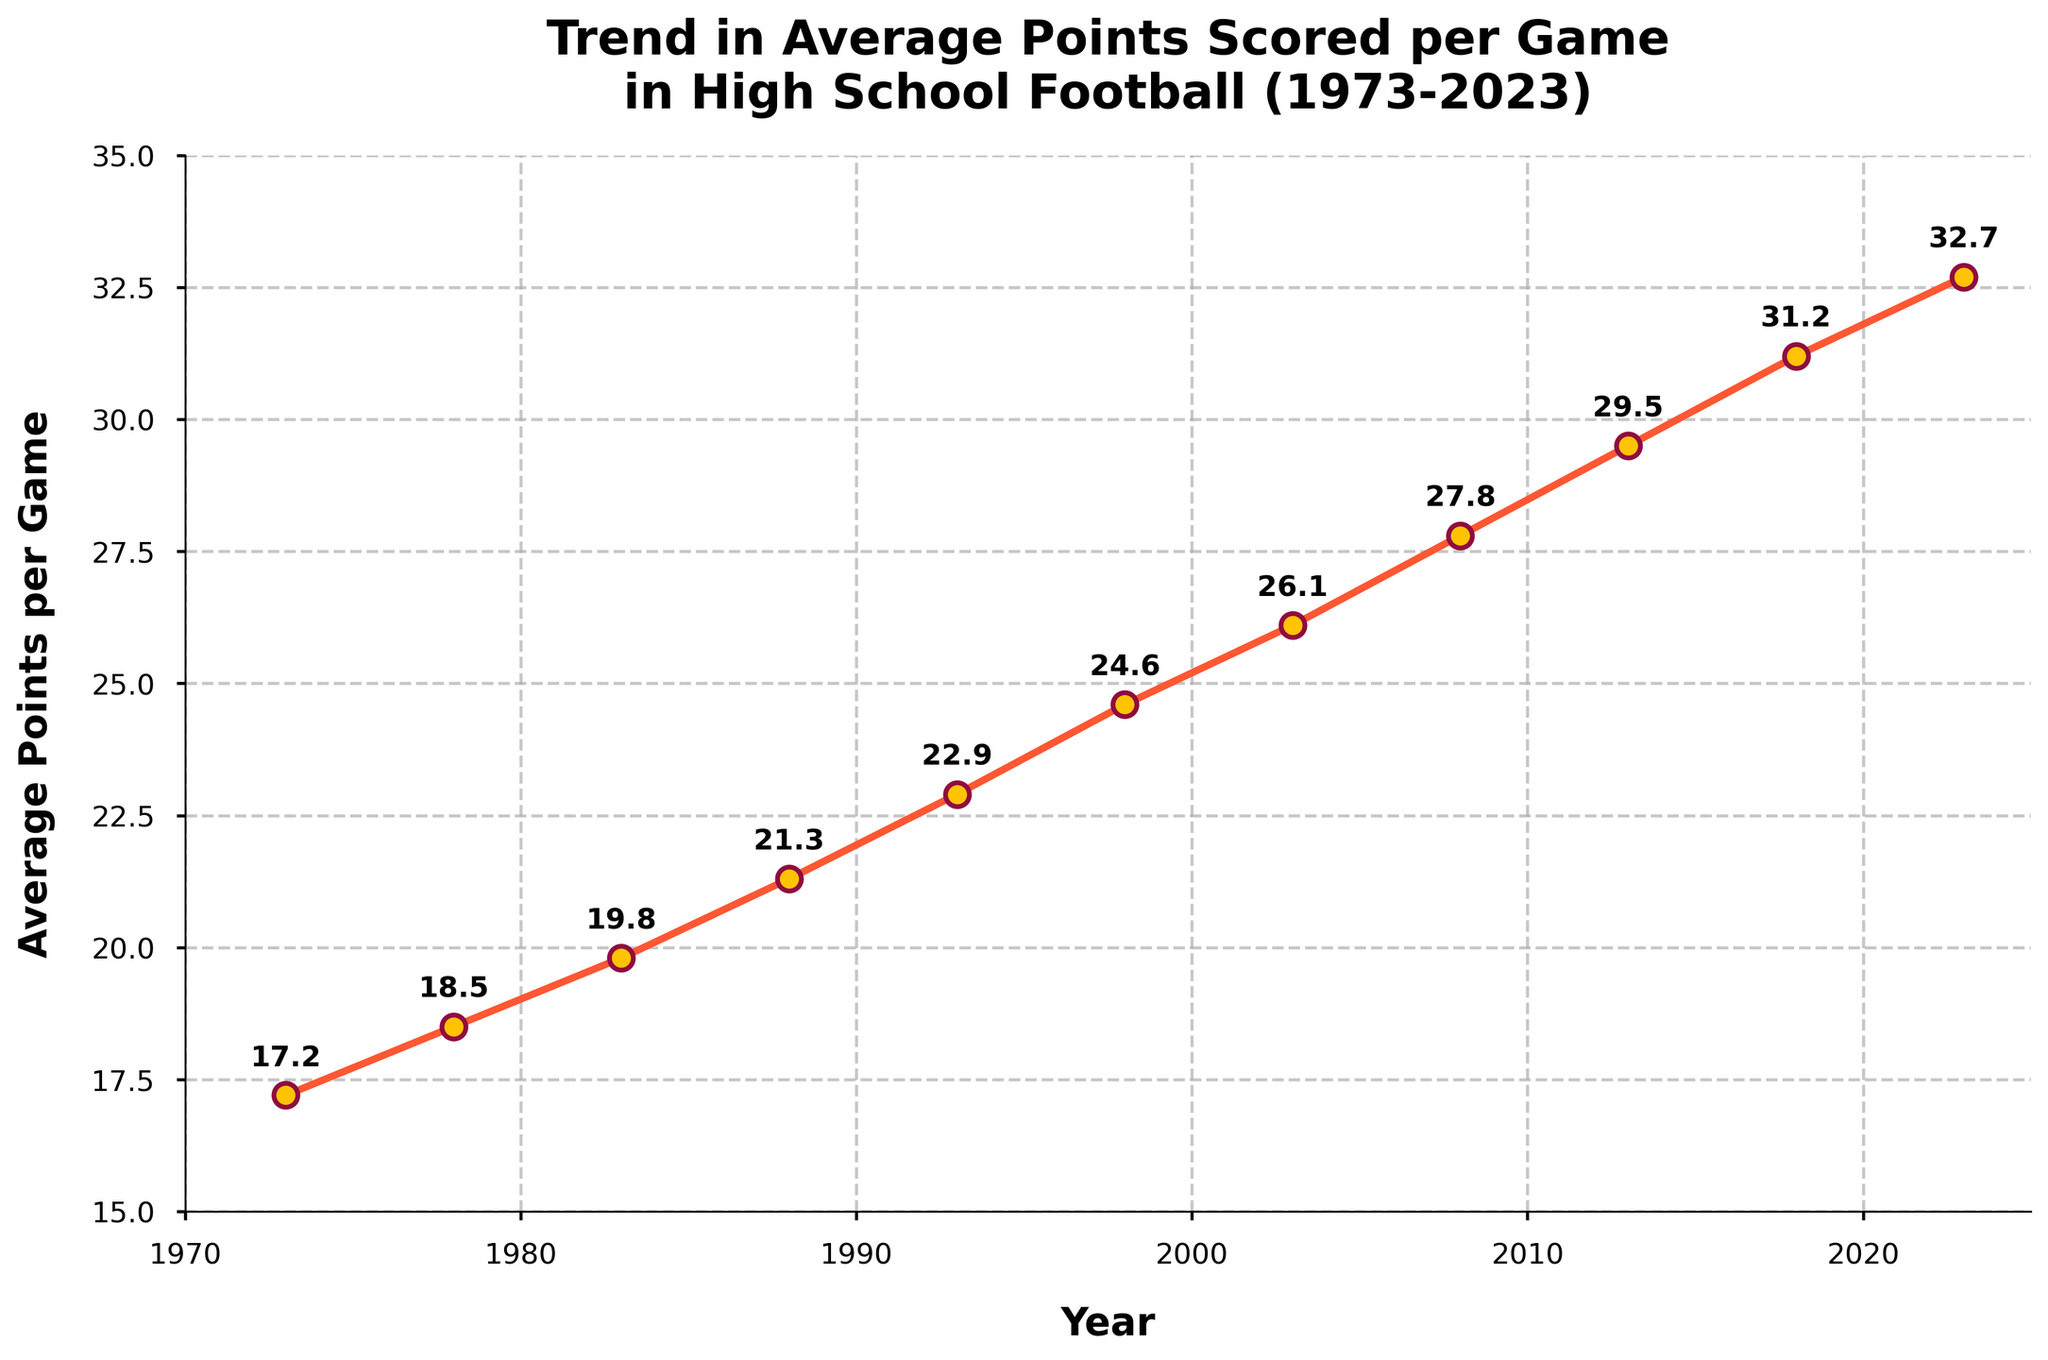What's the overall trend in average points scored per game from 1973 to 2023? By observing the line plot, we can see a generally upward trend in the average points scored per game over the years from 1973 to 2023, with fluctuations but a consistent rise overall.
Answer: Upward trend What was the average points per game in 2003? On the line chart, find the year 2003 on the x-axis and follow it up to the corresponding data point. The value provided is 26.1 points per game.
Answer: 26.1 Between which consecutive years did the average points per game increase the most? Inspect the plot for the steepest increase in the line. The interval between 2013 and 2018 shows the steepest rise. In numerical terms: 2018's 31.2 minus 2013's 29.5 equals 1.7. This is the largest difference when compared to other consecutive years.
Answer: 2013 to 2018 How much did the average points per game increase from 1973 to 2023? Subtract the value in 1973 from the value in 2023: 32.7 - 17.2 = 15.5.
Answer: 15.5 What years correspond to the annotations on the plot? The plot shows data points with annotations at each year listed: 1973, 1978, 1983, 1988, 1993, 1998, 2003, 2008, 2013, 2018, and 2023.
Answer: 1973, 1978, 1983, 1988, 1993, 1998, 2003, 2008, 2013, 2018, 2023 What is the average annual increase in points per game over the 50 years? Compute the total increase: 32.7 (2023) - 17.2 (1973) = 15.5. Divide by the time span: 15.5 / 50 = 0.31 points per year.
Answer: 0.31 points per year By how many points did the average points per game increase from 1983 to 1998? Subtract the 1983 value from the 1998 value: 24.6 - 19.8 = 4.8 points.
Answer: 4.8 Which year had an average points per game closest to 22 points? On the plot, the year closest to 22 points per game is 1993, with a value of 22.9.
Answer: 1993 Is there any year in which the average points per game decreased compared to the previous year? By examining the plot, we see that there is a continuous increase in all successive years without any decreases.
Answer: No What can be inferred about the trend in high school football offensive performance over the last 50 years? The plot indicates that the average points scored per game have steadily increased, suggesting an upward trend in offensive performance and scoring efficiency in high school football over the years.
Answer: Increased offensive performance 